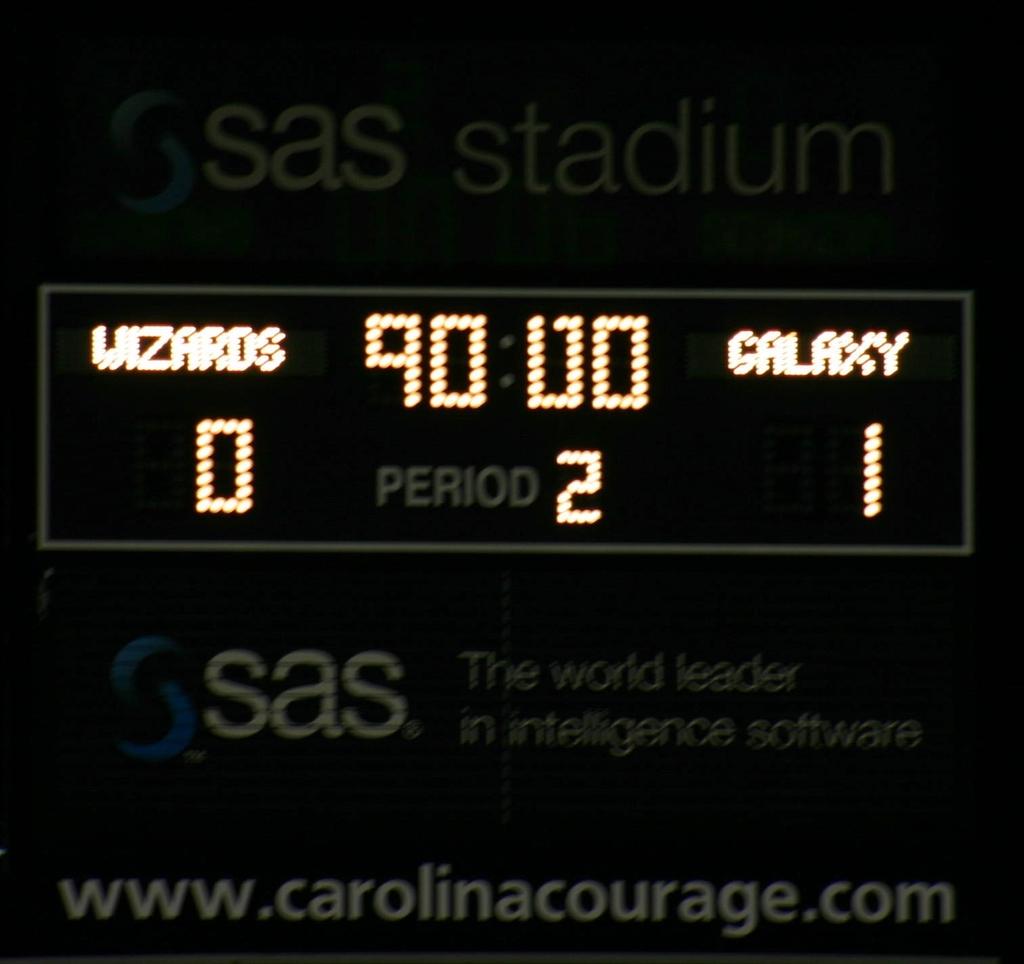What stadium is this?
Your response must be concise. Sas. 